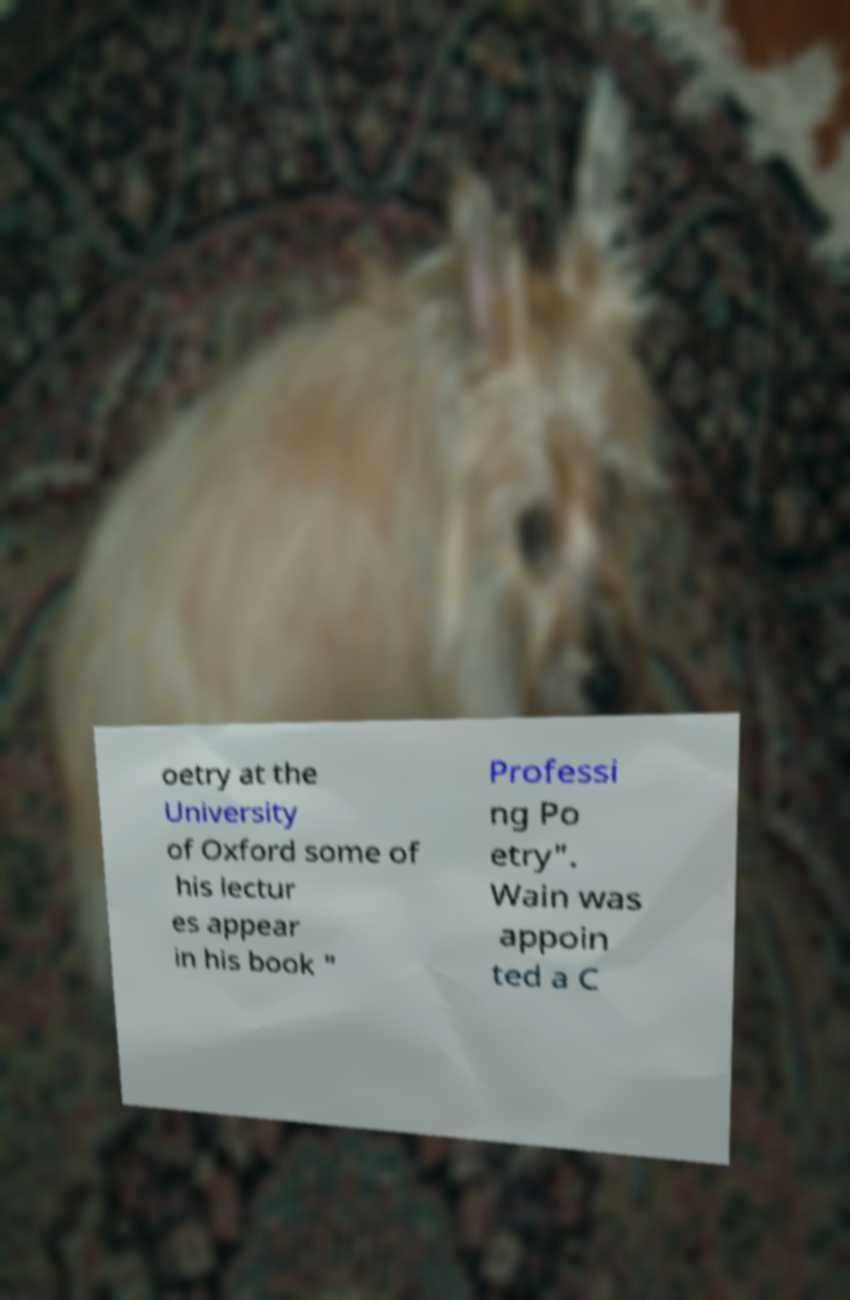Could you assist in decoding the text presented in this image and type it out clearly? oetry at the University of Oxford some of his lectur es appear in his book " Professi ng Po etry". Wain was appoin ted a C 